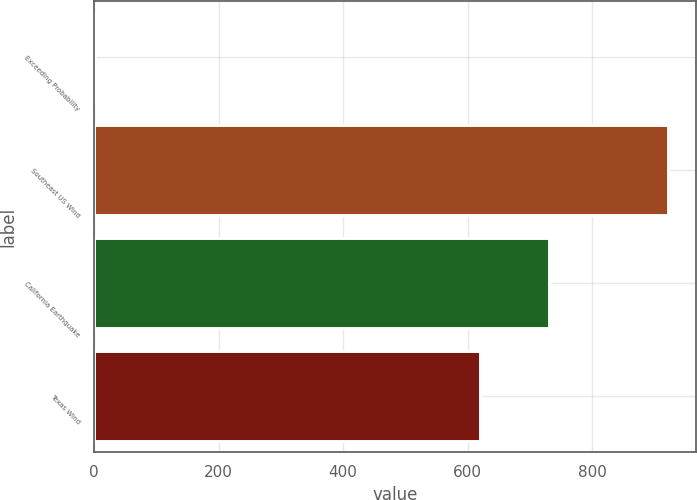Convert chart. <chart><loc_0><loc_0><loc_500><loc_500><bar_chart><fcel>Exceeding Probability<fcel>Southeast US Wind<fcel>California Earthquake<fcel>Texas Wind<nl><fcel>1<fcel>921<fcel>731<fcel>620<nl></chart> 